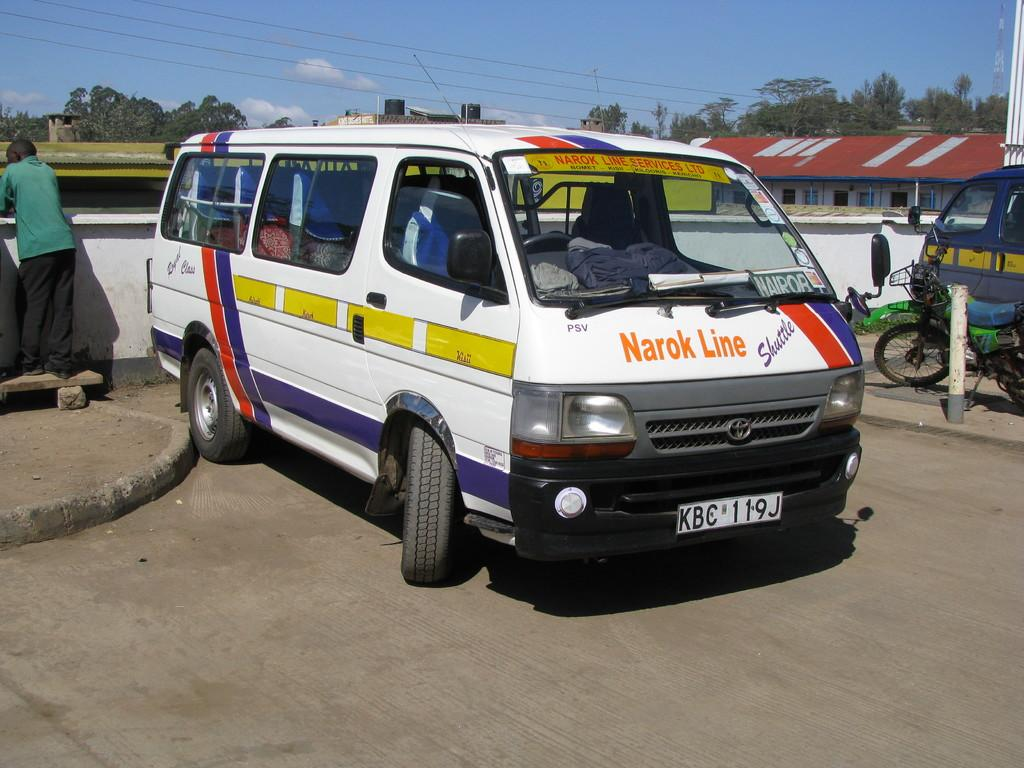What type of vehicle is in the image? There is a white van in the image. Where is the van located? The van is on the road. What can be seen on the left side of the image? There is a person standing on a wooden plank on the left side of the image. What is visible in the background of the image? There are trees and the sky visible in the background of the image. What type of waves can be seen crashing on the shore in the image? There are no waves or shore visible in the image; it features a white van on the road, a person on a wooden plank, trees, and the sky. 